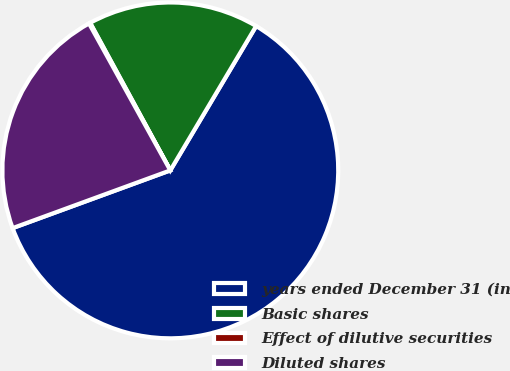<chart> <loc_0><loc_0><loc_500><loc_500><pie_chart><fcel>years ended December 31 (in<fcel>Basic shares<fcel>Effect of dilutive securities<fcel>Diluted shares<nl><fcel>60.87%<fcel>16.46%<fcel>0.12%<fcel>22.54%<nl></chart> 